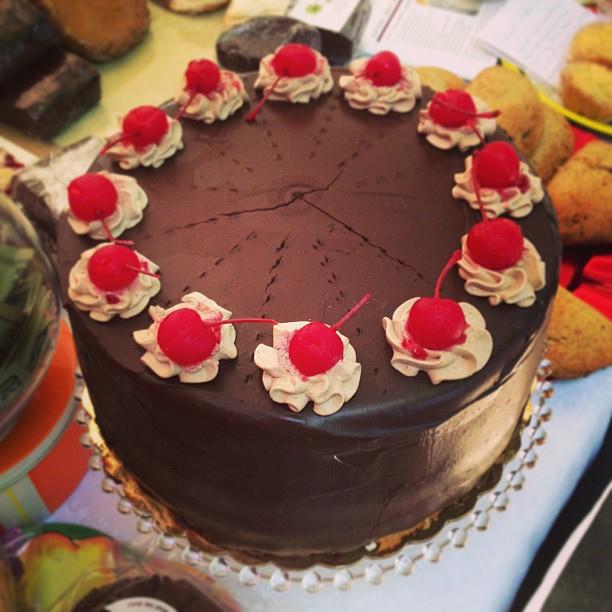How many slices are there?
Concise answer only. 12. What is on top of the cake?
Write a very short answer. Cherries. What kind of icing is on the cake?
Quick response, please. Chocolate. 